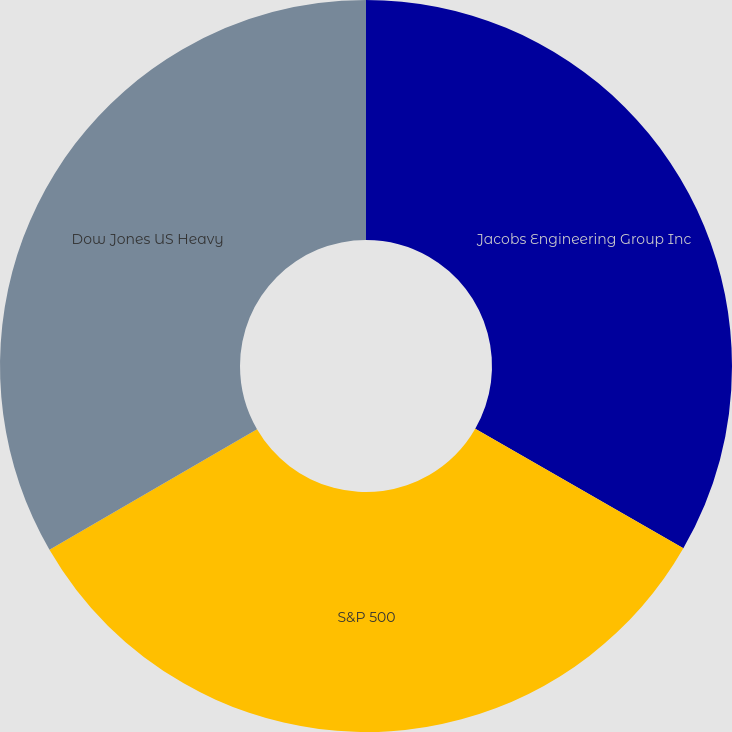Convert chart. <chart><loc_0><loc_0><loc_500><loc_500><pie_chart><fcel>Jacobs Engineering Group Inc<fcel>S&P 500<fcel>Dow Jones US Heavy<nl><fcel>33.3%<fcel>33.33%<fcel>33.37%<nl></chart> 